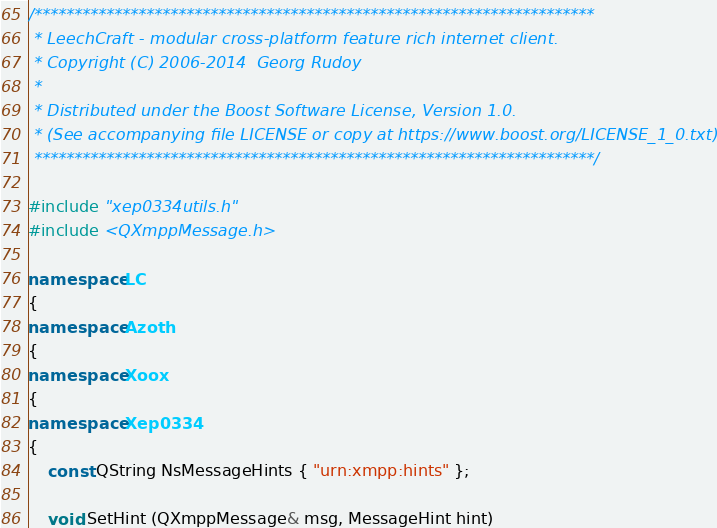Convert code to text. <code><loc_0><loc_0><loc_500><loc_500><_C++_>/**********************************************************************
 * LeechCraft - modular cross-platform feature rich internet client.
 * Copyright (C) 2006-2014  Georg Rudoy
 *
 * Distributed under the Boost Software License, Version 1.0.
 * (See accompanying file LICENSE or copy at https://www.boost.org/LICENSE_1_0.txt)
 **********************************************************************/

#include "xep0334utils.h"
#include <QXmppMessage.h>

namespace LC
{
namespace Azoth
{
namespace Xoox
{
namespace Xep0334
{
	const QString NsMessageHints { "urn:xmpp:hints" };

	void SetHint (QXmppMessage& msg, MessageHint hint)</code> 